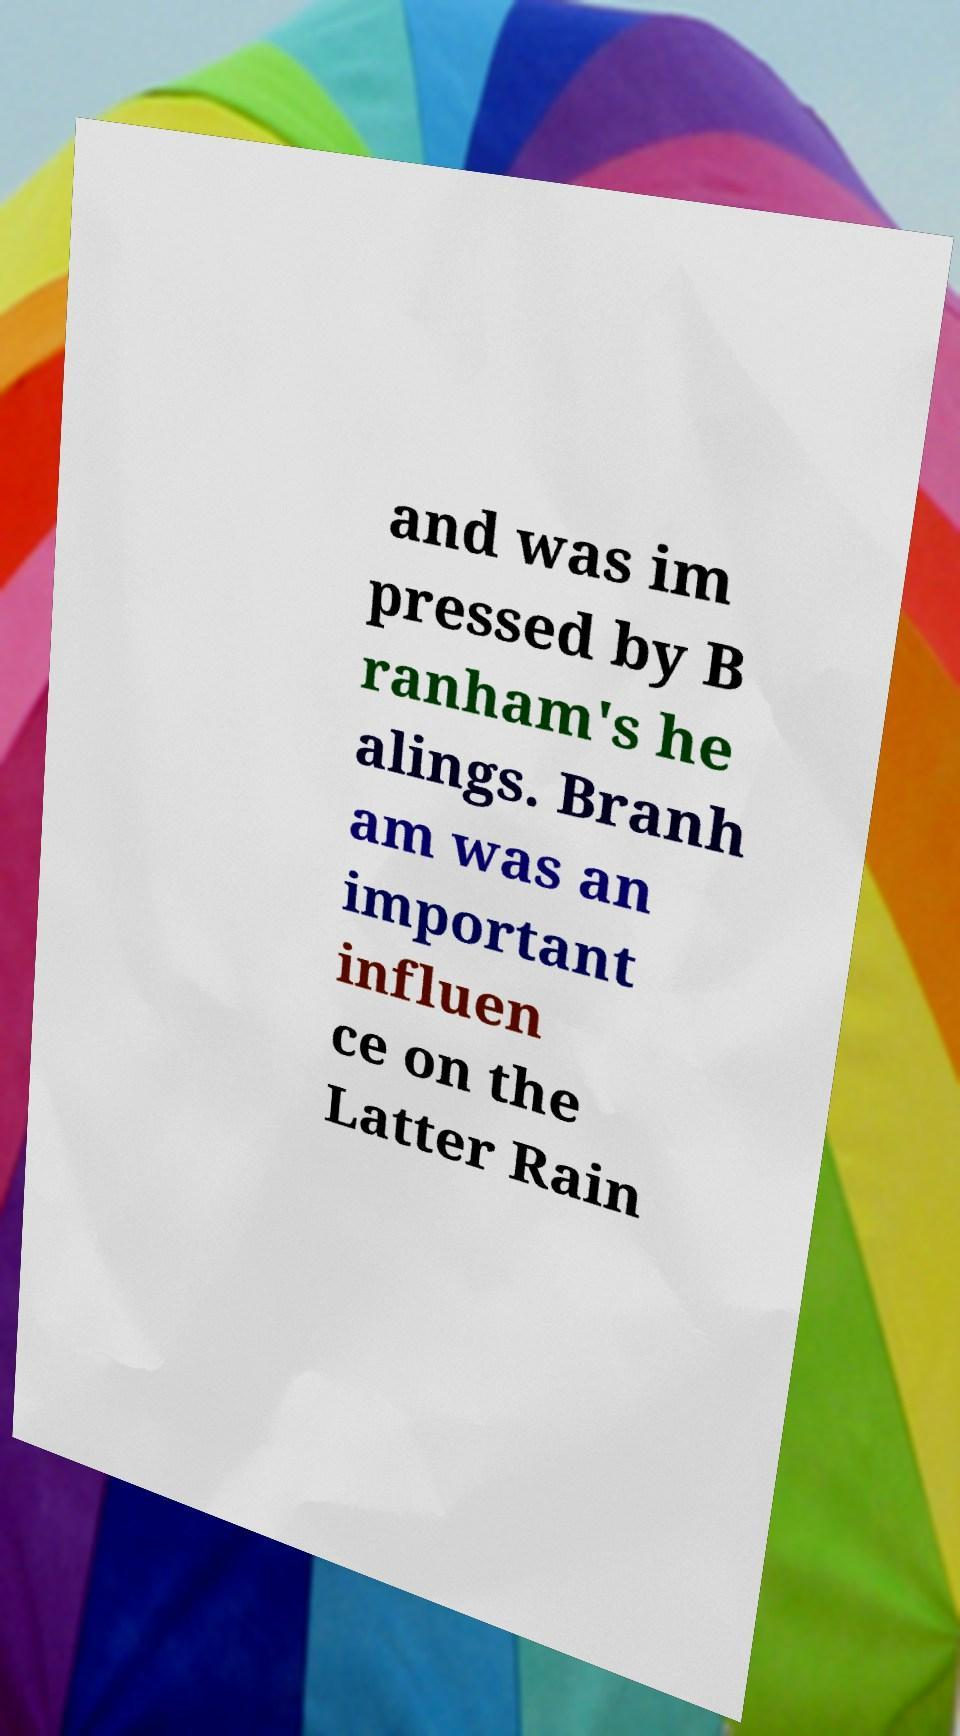Can you accurately transcribe the text from the provided image for me? and was im pressed by B ranham's he alings. Branh am was an important influen ce on the Latter Rain 